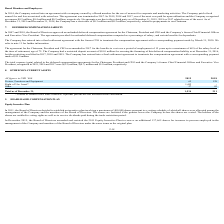According to Nordic American Tankers Limited's financial document, What does the Right of Use Asset refer to? relates to certain office lease contracts. The document states: "* relates to certain office lease contracts. Optional periods are not included in the calculation...." Also, What are the respective values of the company's fixture, furniture and equipment in 2018 and 2019? The document shows two values: 128 and 65 (in thousands). From the document: "Fixture, Furniture and Equipment 65 128 Fixture, Furniture and Equipment 65 128..." Also, What are the respective values of the company's other non-current assets in 2018 and 2019? The document shows two values: 83 and 57 (in thousands). From the document: "Other 57 83 Other 57 83..." Also, can you calculate: What is the average other non-current assets as at December 31, 2018 and 2019? To answer this question, I need to perform calculations using the financial data. The calculation is: (83 + 57)/2, which equals 70 (in thousands). This is based on the information: "Other 57 83 Other 57 83..." The key data points involved are: 57, 83. Also, can you calculate: What is the change in Fixture, Furniture and Equipment between 2018 and 2019? Based on the calculation: 128-65, the result is 63 (in thousands). This is based on the information: "Fixture, Furniture and Equipment 65 128 Fixture, Furniture and Equipment 65 128..." The key data points involved are: 128, 65. Also, can you calculate: What is the value of the other non-current assets as at December 31, 2018 as a percentage of the value of other non-current assets in 2019? Based on the calculation: 83/57 , the result is 145.61 (percentage). This is based on the information: "Other 57 83 Other 57 83..." The key data points involved are: 57, 83. 